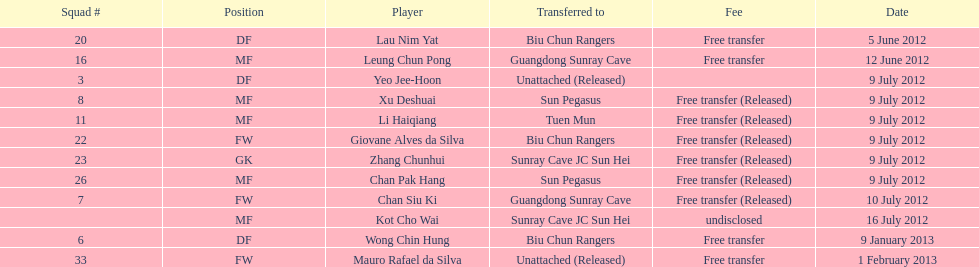What position is next to squad # 3? DF. 